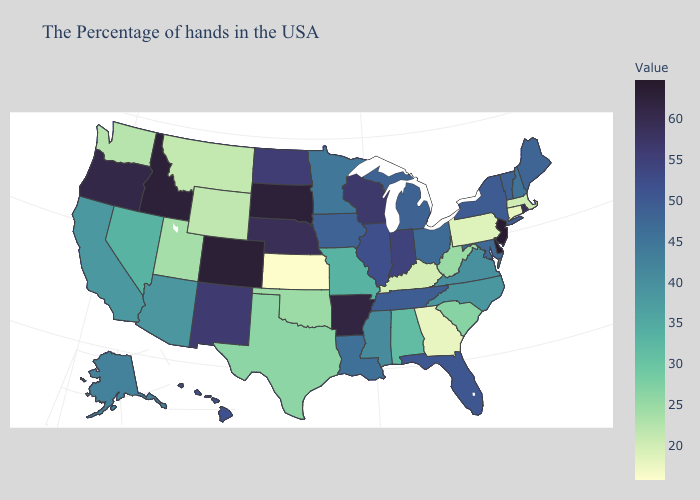Does Maine have a higher value than Washington?
Short answer required. Yes. Does Connecticut have a higher value than Colorado?
Be succinct. No. Does North Carolina have the highest value in the USA?
Concise answer only. No. Does Indiana have a higher value than Vermont?
Write a very short answer. Yes. 